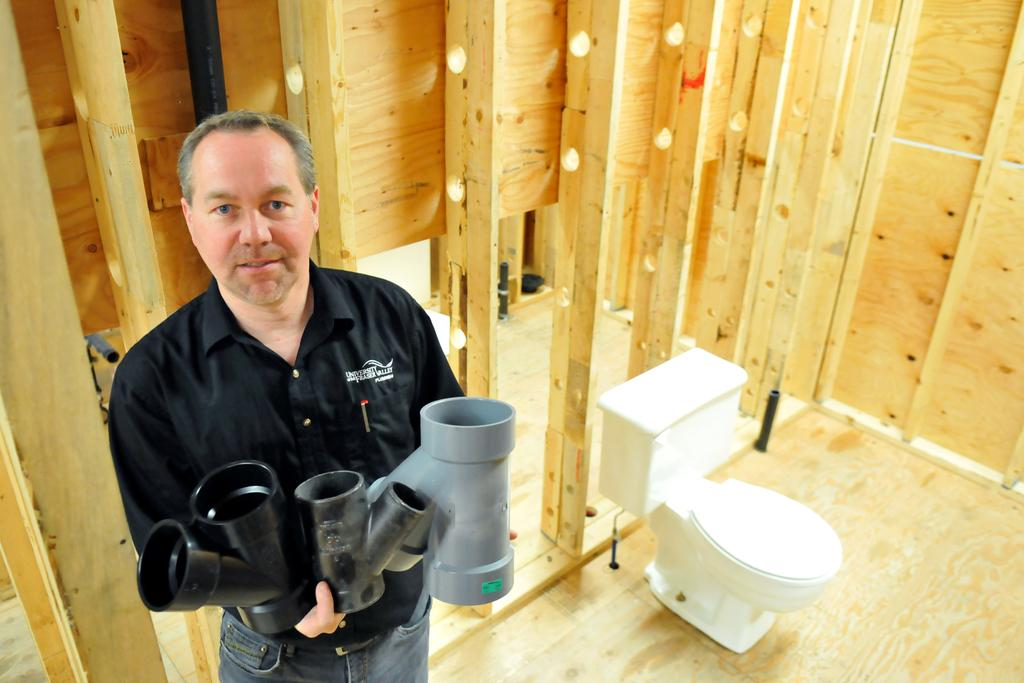Who is present in the image? There is a man in the image. What is the man holding in the image? The man is holding pipes with his hands. Where are the pipes located in the image? The pipes are on the left side of the image. What other object can be seen in the image? There is a toilet seat in the image. Where is the toilet seat located in the image? The toilet seat is on the right side of the image. What time of day is it in the image, and is there a lamp present? The time of day cannot be determined from the image, and there is no lamp present. 